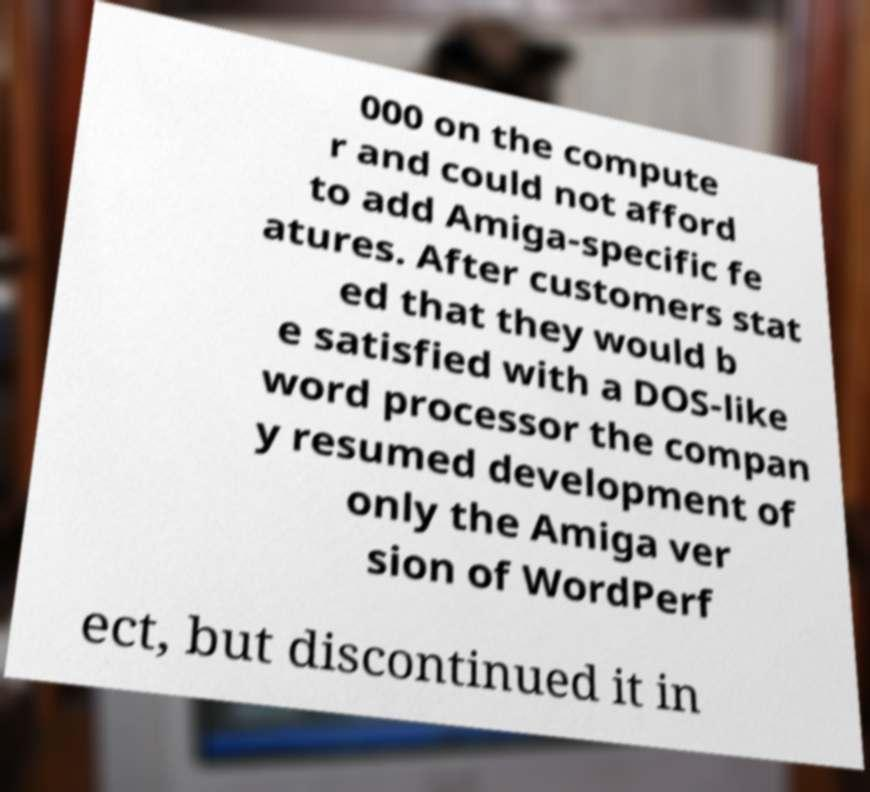What messages or text are displayed in this image? I need them in a readable, typed format. 000 on the compute r and could not afford to add Amiga-specific fe atures. After customers stat ed that they would b e satisfied with a DOS-like word processor the compan y resumed development of only the Amiga ver sion of WordPerf ect, but discontinued it in 